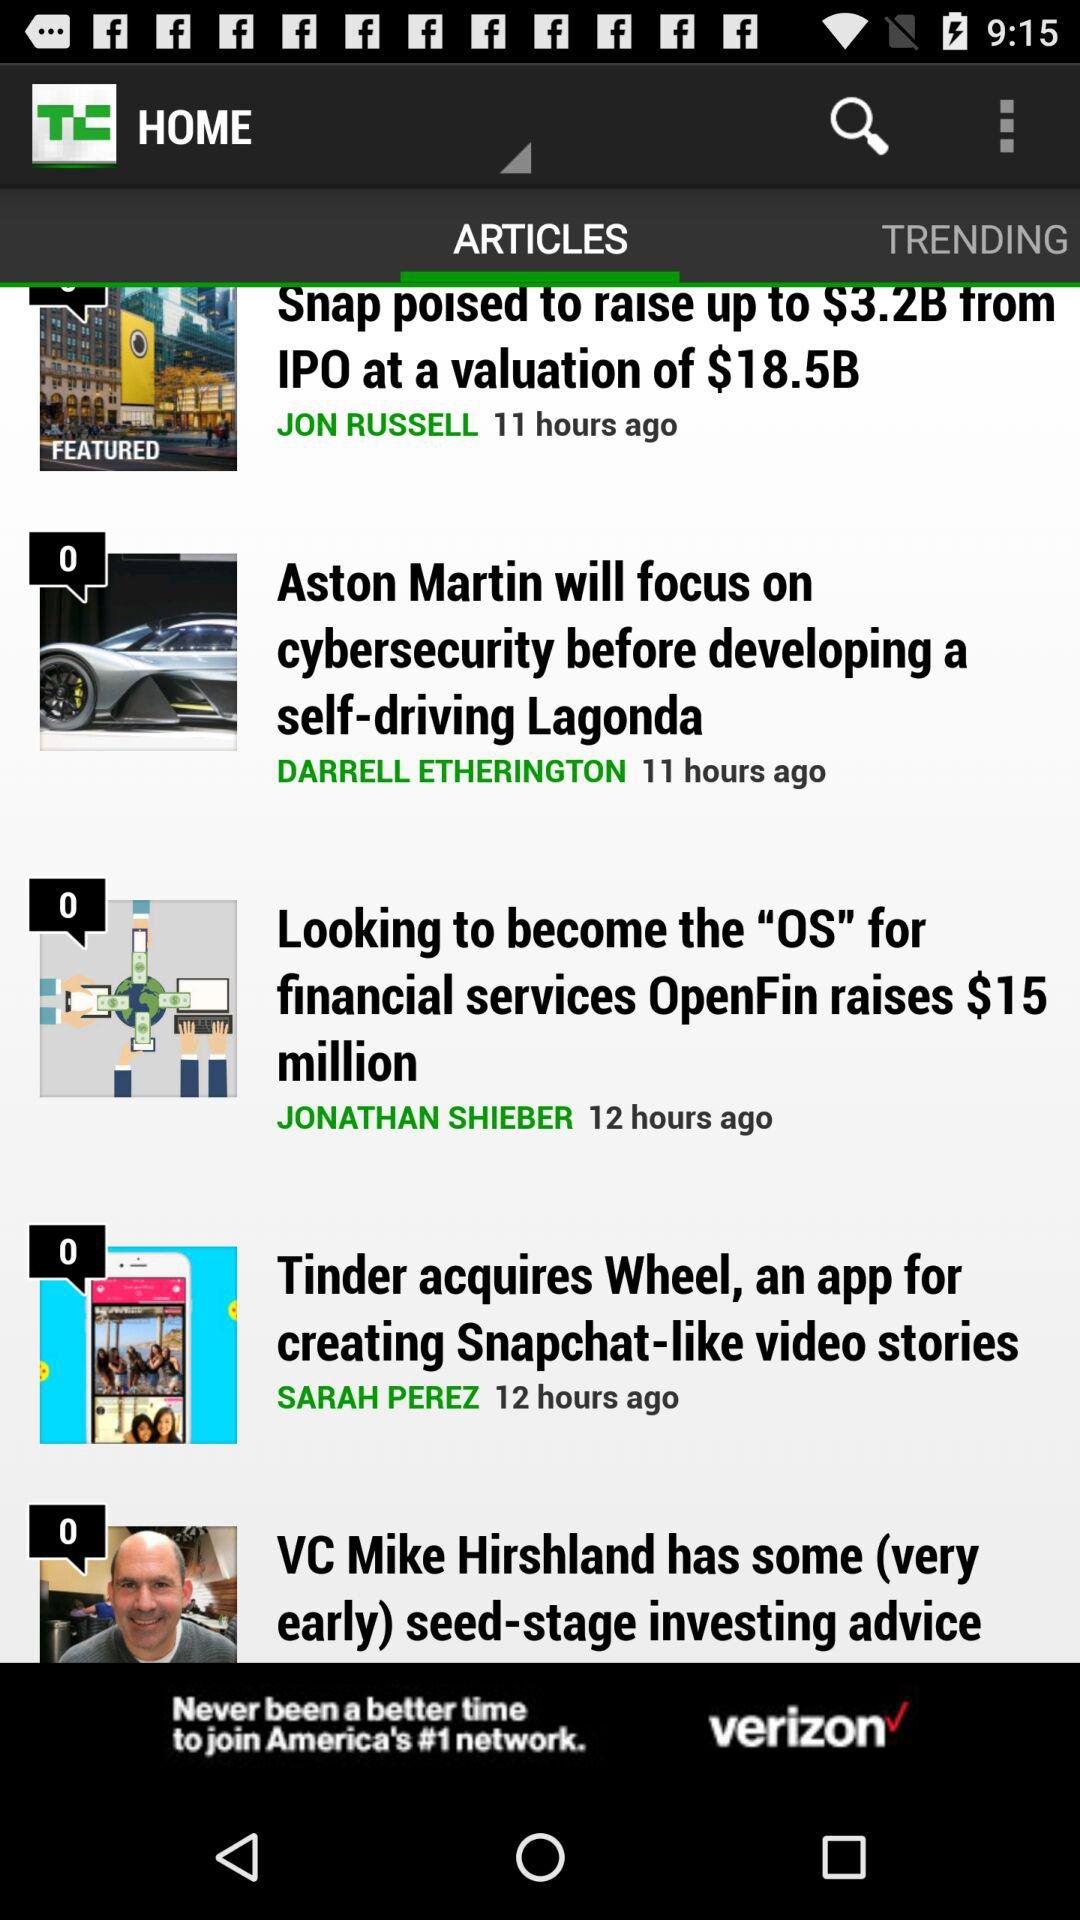What is the valuation of snap posted?
When the provided information is insufficient, respond with <no answer>. <no answer> 